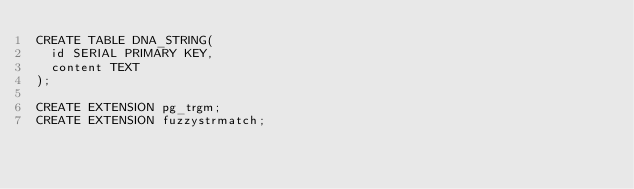Convert code to text. <code><loc_0><loc_0><loc_500><loc_500><_SQL_>CREATE TABLE DNA_STRING(
  id SERIAL PRIMARY KEY,
  content TEXT
);

CREATE EXTENSION pg_trgm;
CREATE EXTENSION fuzzystrmatch;</code> 